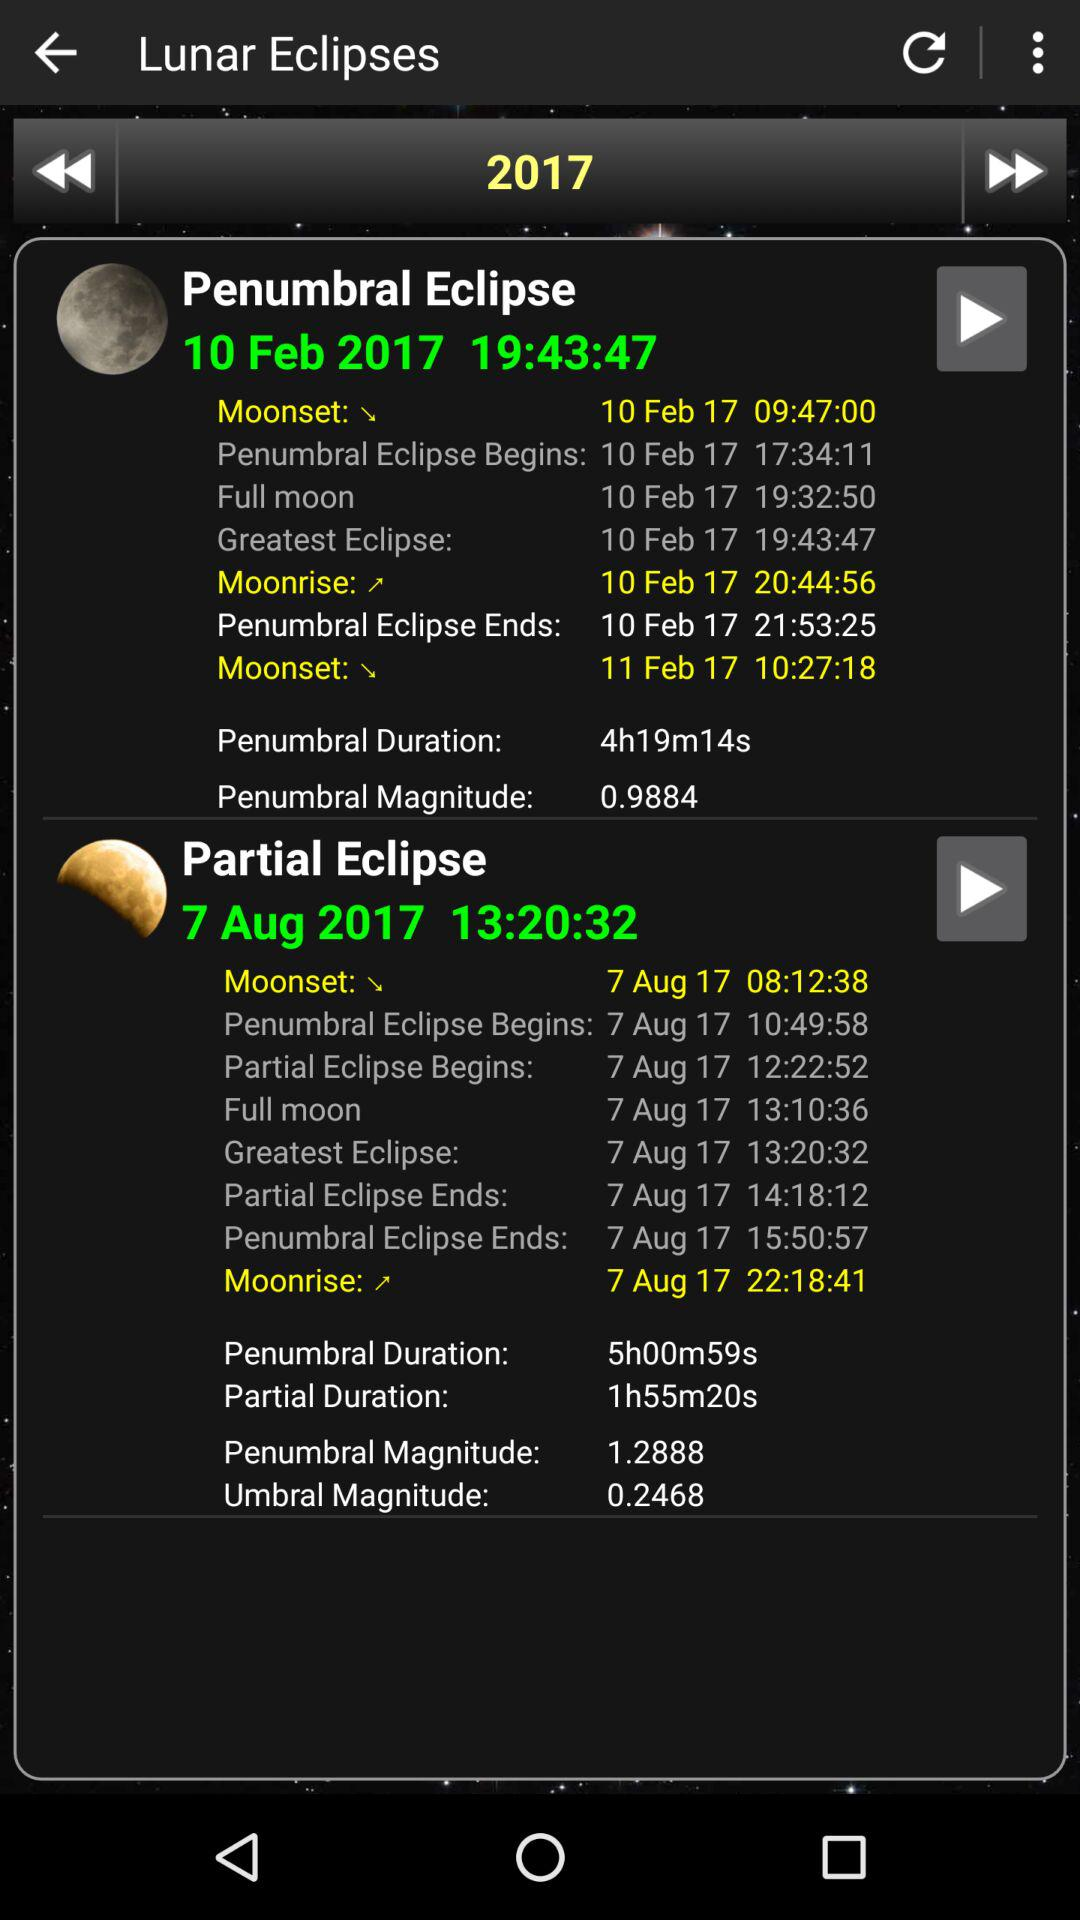What is the time when the penumbral eclipse ends? The time when the penumbral eclipse ends is 21:53:25. 